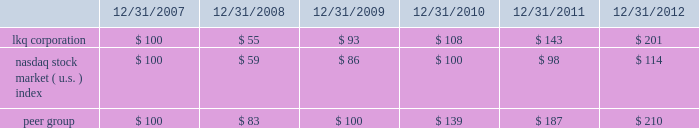Comparison of cumulative return among lkq corporation , the nasdaq stock market ( u.s. ) index and the peer group .
This stock performance information is "furnished" and shall not be deemed to be "soliciting material" or subject to rule 14a , shall not be deemed "filed" for purposes of section 18 of the securities exchange act of 1934 or otherwise subject to the liabilities of that section , and shall not be deemed incorporated by reference in any filing under the securities act of 1933 or the securities exchange act of 1934 , whether made before or after the date of this report and irrespective of any general incorporation by reference language in any such filing , except to the extent that it specifically incorporates the information by reference .
Information about our common stock that may be issued under our equity compensation plans as of december 31 , 2012 included in part iii , item 12 of this annual report on form 10-k is incorporated herein by reference. .
What was the difference in percentage of cumulative return for lkq corporation and the peer group for the five years ended 12/31/2012? 
Computations: ((210 - 100) / 100)
Answer: 1.1. 